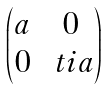Convert formula to latex. <formula><loc_0><loc_0><loc_500><loc_500>\begin{pmatrix} a & 0 \\ 0 & \ t i a \end{pmatrix}</formula> 